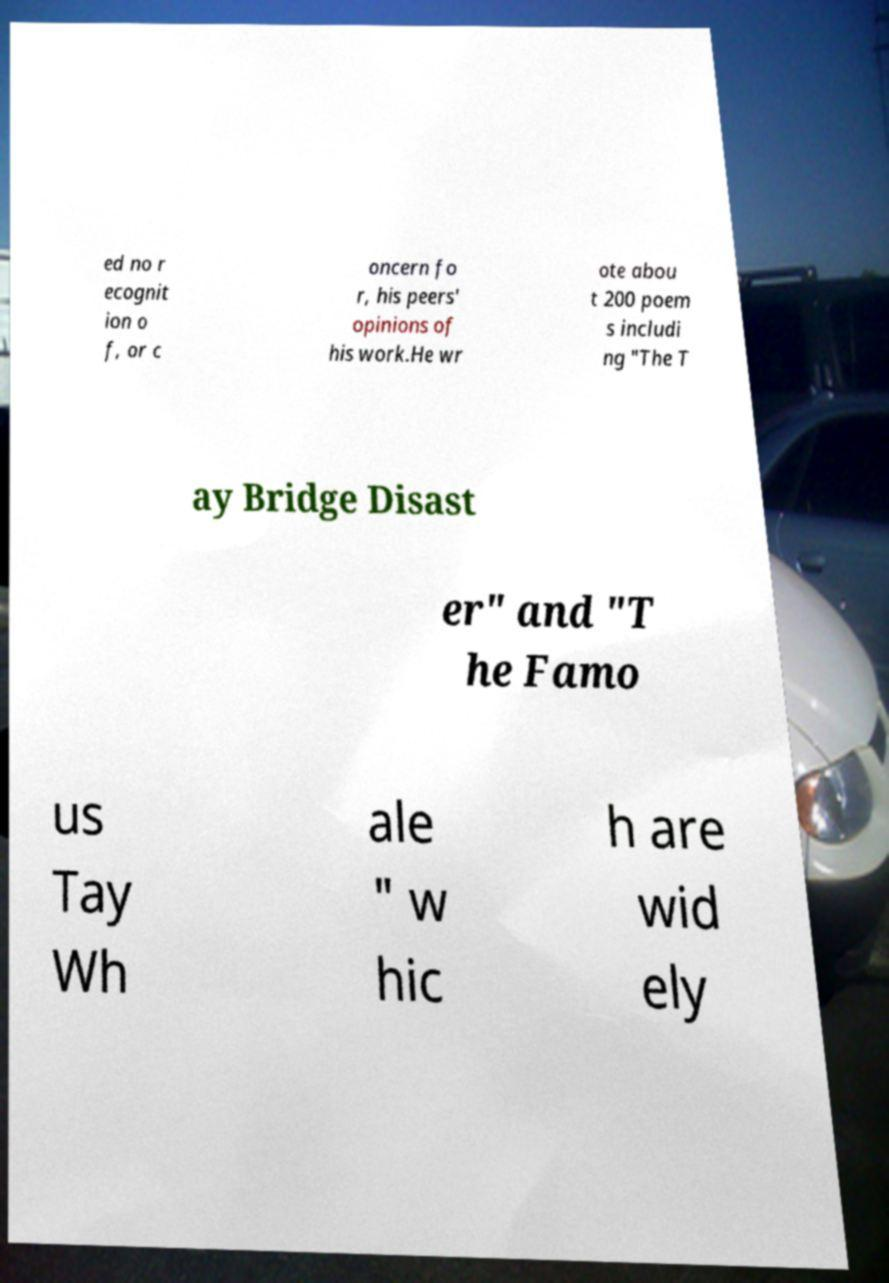Can you read and provide the text displayed in the image?This photo seems to have some interesting text. Can you extract and type it out for me? ed no r ecognit ion o f, or c oncern fo r, his peers' opinions of his work.He wr ote abou t 200 poem s includi ng "The T ay Bridge Disast er" and "T he Famo us Tay Wh ale " w hic h are wid ely 